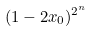Convert formula to latex. <formula><loc_0><loc_0><loc_500><loc_500>( 1 - 2 x _ { 0 } ) ^ { 2 ^ { n } }</formula> 